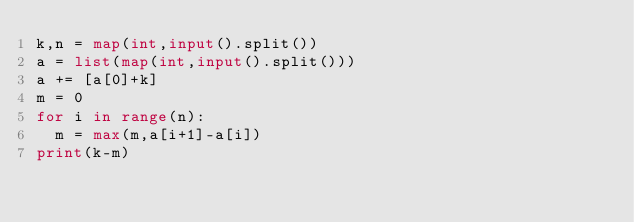Convert code to text. <code><loc_0><loc_0><loc_500><loc_500><_Python_>k,n = map(int,input().split())
a = list(map(int,input().split()))
a += [a[0]+k]
m = 0
for i in range(n):
  m = max(m,a[i+1]-a[i])
print(k-m)</code> 